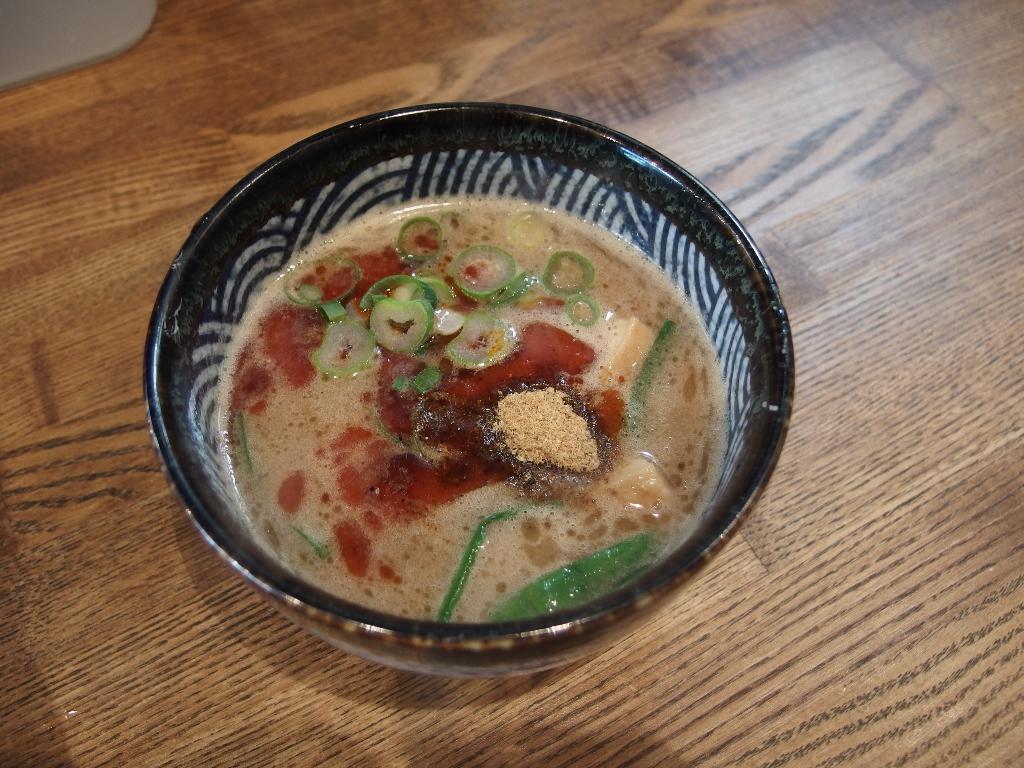Describe this image in one or two sentences. The picture consists of a wooden table, on the table there is a bowl with soup in it. 